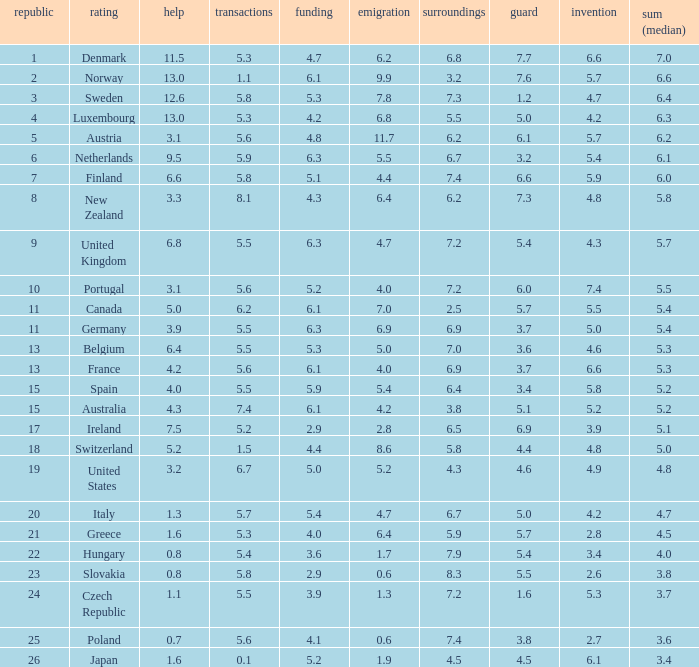What country has a 5.5 mark for security? Slovakia. 